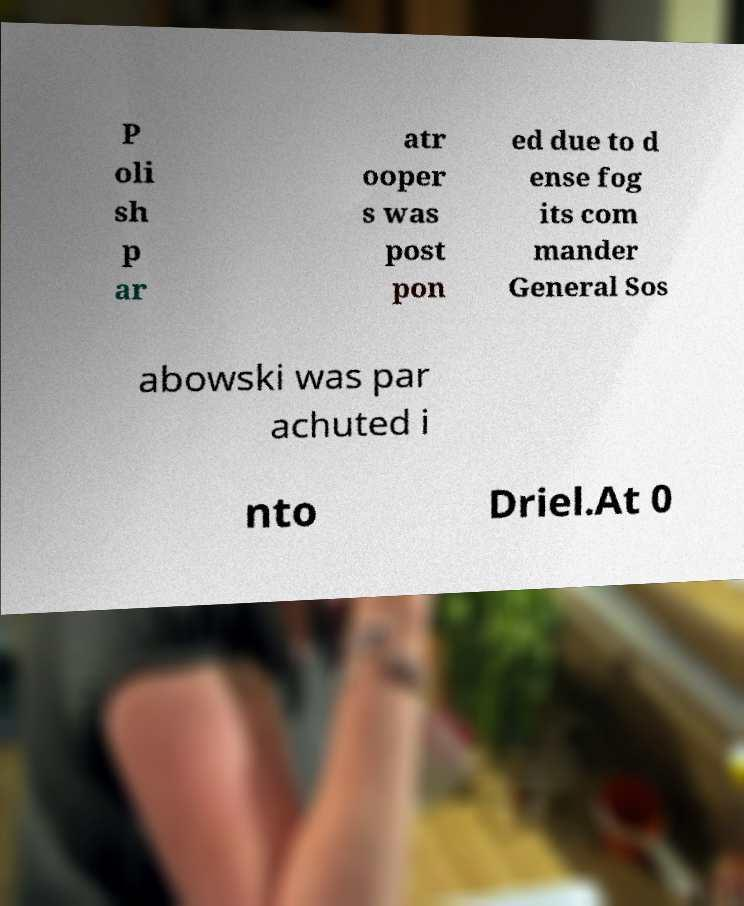I need the written content from this picture converted into text. Can you do that? P oli sh p ar atr ooper s was post pon ed due to d ense fog its com mander General Sos abowski was par achuted i nto Driel.At 0 